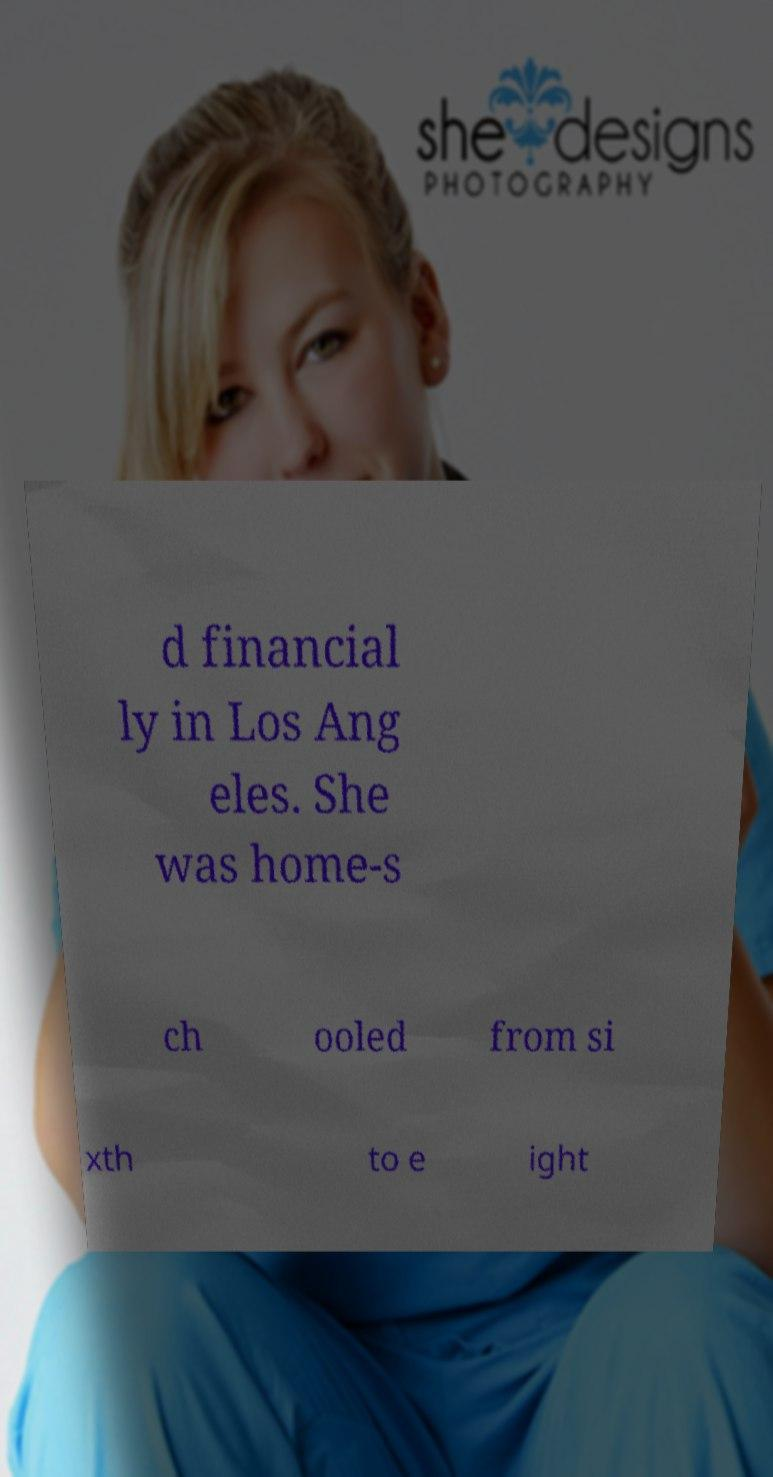What messages or text are displayed in this image? I need them in a readable, typed format. d financial ly in Los Ang eles. She was home-s ch ooled from si xth to e ight 